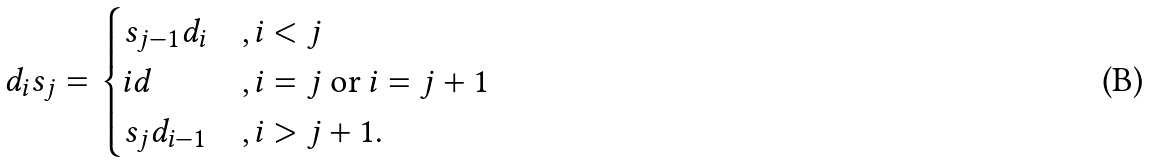Convert formula to latex. <formula><loc_0><loc_0><loc_500><loc_500>d _ { i } s _ { j } = \begin{cases} s _ { j - 1 } d _ { i } & , i < j \\ i d & , i = j \text { or } i = j + 1 \\ s _ { j } d _ { i - 1 } & , i > j + 1 . \end{cases}</formula> 